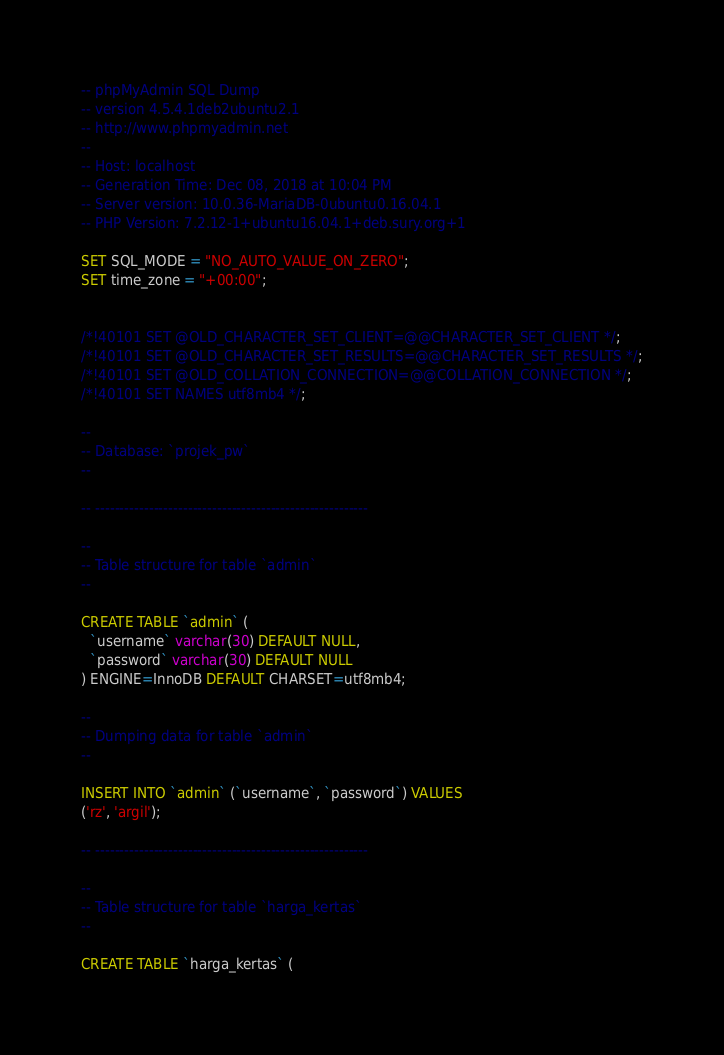<code> <loc_0><loc_0><loc_500><loc_500><_SQL_>-- phpMyAdmin SQL Dump
-- version 4.5.4.1deb2ubuntu2.1
-- http://www.phpmyadmin.net
--
-- Host: localhost
-- Generation Time: Dec 08, 2018 at 10:04 PM
-- Server version: 10.0.36-MariaDB-0ubuntu0.16.04.1
-- PHP Version: 7.2.12-1+ubuntu16.04.1+deb.sury.org+1

SET SQL_MODE = "NO_AUTO_VALUE_ON_ZERO";
SET time_zone = "+00:00";


/*!40101 SET @OLD_CHARACTER_SET_CLIENT=@@CHARACTER_SET_CLIENT */;
/*!40101 SET @OLD_CHARACTER_SET_RESULTS=@@CHARACTER_SET_RESULTS */;
/*!40101 SET @OLD_COLLATION_CONNECTION=@@COLLATION_CONNECTION */;
/*!40101 SET NAMES utf8mb4 */;

--
-- Database: `projek_pw`
--

-- --------------------------------------------------------

--
-- Table structure for table `admin`
--

CREATE TABLE `admin` (
  `username` varchar(30) DEFAULT NULL,
  `password` varchar(30) DEFAULT NULL
) ENGINE=InnoDB DEFAULT CHARSET=utf8mb4;

--
-- Dumping data for table `admin`
--

INSERT INTO `admin` (`username`, `password`) VALUES
('rz', 'argil');

-- --------------------------------------------------------

--
-- Table structure for table `harga_kertas`
--

CREATE TABLE `harga_kertas` (</code> 